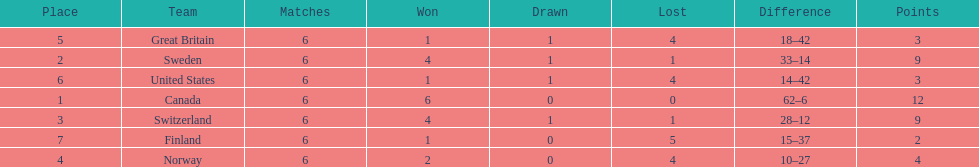What team placed next after sweden? Switzerland. 